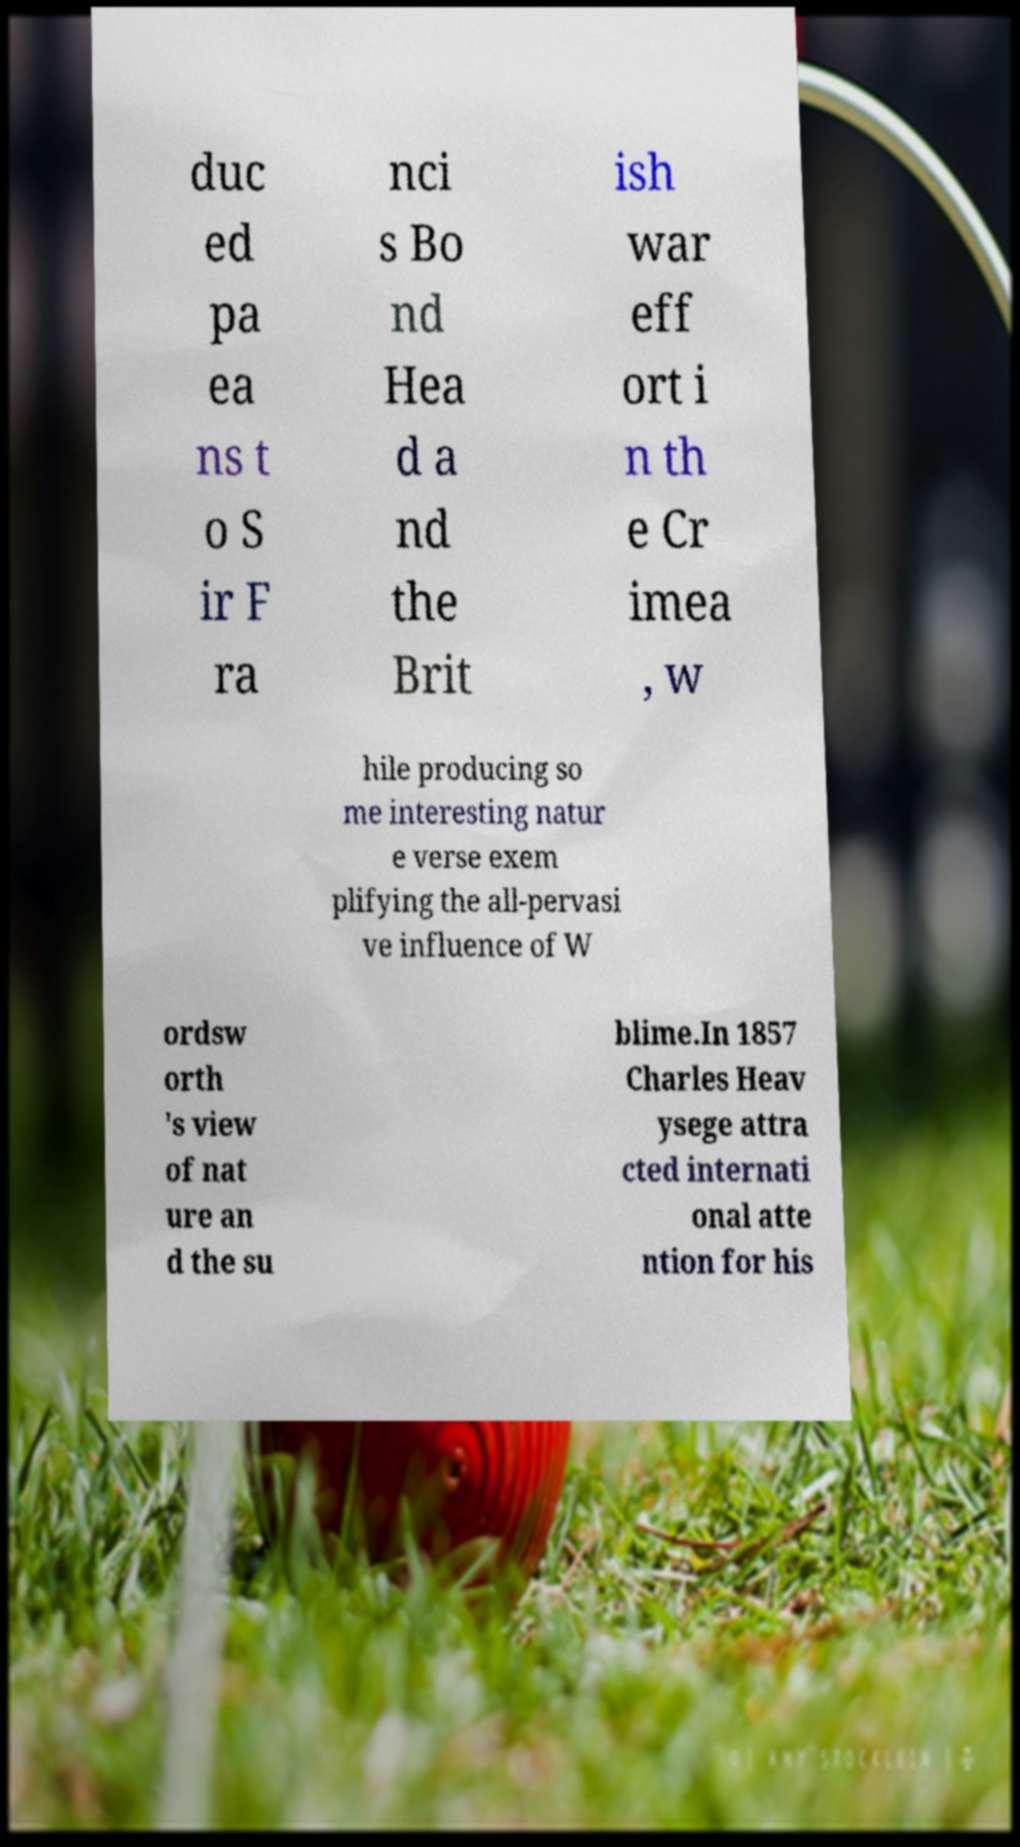Please identify and transcribe the text found in this image. duc ed pa ea ns t o S ir F ra nci s Bo nd Hea d a nd the Brit ish war eff ort i n th e Cr imea , w hile producing so me interesting natur e verse exem plifying the all-pervasi ve influence of W ordsw orth 's view of nat ure an d the su blime.In 1857 Charles Heav ysege attra cted internati onal atte ntion for his 